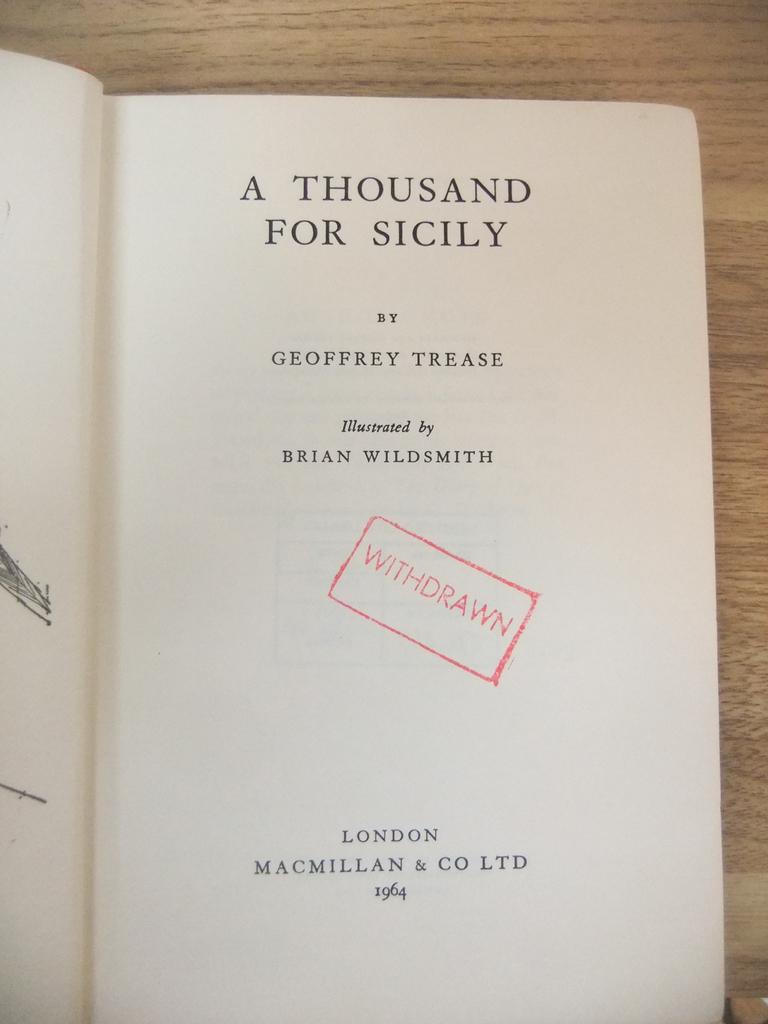Who illustrated the book shown?
Your answer should be compact. Brian wildsmith. What stamp is in the book and what does it say?
Make the answer very short. Withdrawn. 